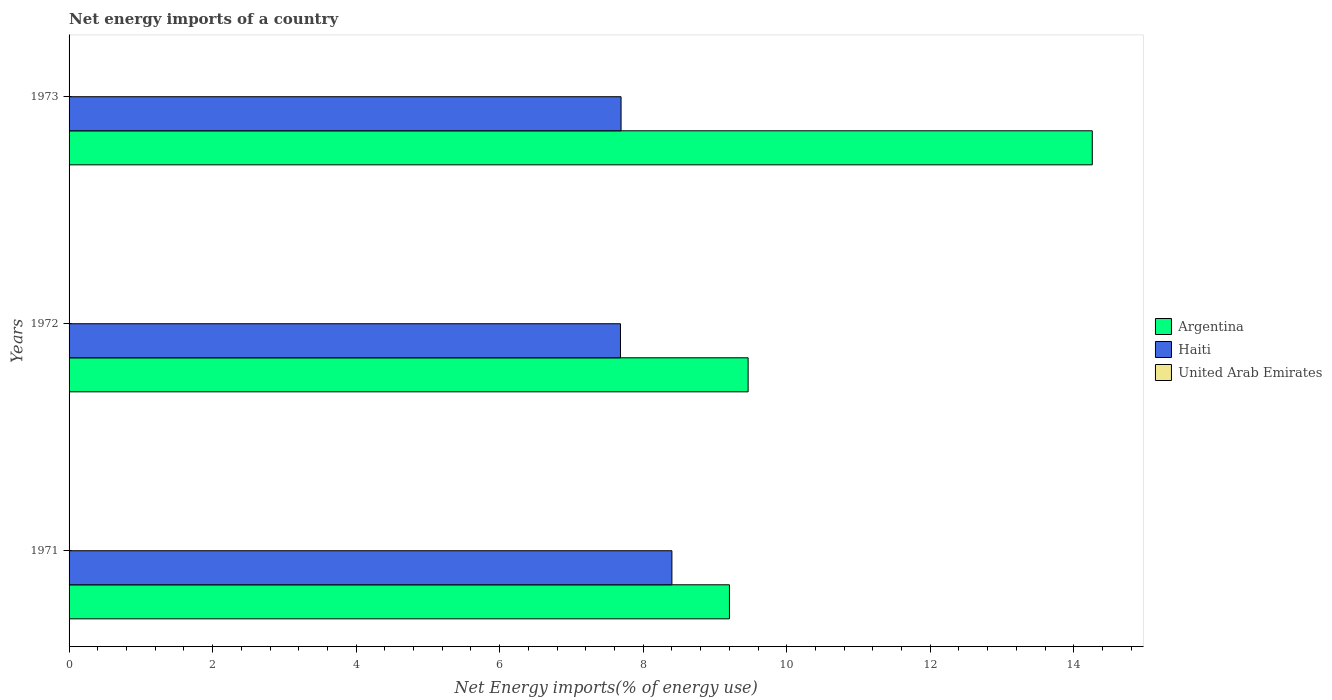How many different coloured bars are there?
Make the answer very short. 2. Are the number of bars per tick equal to the number of legend labels?
Your answer should be compact. No. Are the number of bars on each tick of the Y-axis equal?
Provide a short and direct response. Yes. How many bars are there on the 3rd tick from the top?
Give a very brief answer. 2. In how many cases, is the number of bars for a given year not equal to the number of legend labels?
Give a very brief answer. 3. What is the net energy imports in Haiti in 1971?
Ensure brevity in your answer.  8.4. Across all years, what is the maximum net energy imports in Argentina?
Give a very brief answer. 14.26. Across all years, what is the minimum net energy imports in Haiti?
Give a very brief answer. 7.68. What is the total net energy imports in Haiti in the graph?
Provide a succinct answer. 23.78. What is the difference between the net energy imports in Haiti in 1972 and that in 1973?
Give a very brief answer. -0.01. What is the difference between the net energy imports in Argentina in 1971 and the net energy imports in Haiti in 1972?
Provide a short and direct response. 1.52. What is the average net energy imports in Haiti per year?
Ensure brevity in your answer.  7.93. In the year 1973, what is the difference between the net energy imports in Haiti and net energy imports in Argentina?
Provide a succinct answer. -6.57. What is the ratio of the net energy imports in Haiti in 1971 to that in 1973?
Make the answer very short. 1.09. Is the net energy imports in Argentina in 1971 less than that in 1972?
Your answer should be very brief. Yes. Is the difference between the net energy imports in Haiti in 1971 and 1973 greater than the difference between the net energy imports in Argentina in 1971 and 1973?
Provide a short and direct response. Yes. What is the difference between the highest and the second highest net energy imports in Argentina?
Your response must be concise. 4.8. What is the difference between the highest and the lowest net energy imports in Argentina?
Keep it short and to the point. 5.06. Is the sum of the net energy imports in Haiti in 1972 and 1973 greater than the maximum net energy imports in Argentina across all years?
Keep it short and to the point. Yes. Are the values on the major ticks of X-axis written in scientific E-notation?
Offer a terse response. No. Where does the legend appear in the graph?
Offer a very short reply. Center right. How many legend labels are there?
Ensure brevity in your answer.  3. How are the legend labels stacked?
Your answer should be compact. Vertical. What is the title of the graph?
Provide a succinct answer. Net energy imports of a country. Does "Maldives" appear as one of the legend labels in the graph?
Provide a short and direct response. No. What is the label or title of the X-axis?
Give a very brief answer. Net Energy imports(% of energy use). What is the Net Energy imports(% of energy use) of Argentina in 1971?
Offer a very short reply. 9.2. What is the Net Energy imports(% of energy use) in Haiti in 1971?
Your answer should be very brief. 8.4. What is the Net Energy imports(% of energy use) of United Arab Emirates in 1971?
Your answer should be very brief. 0. What is the Net Energy imports(% of energy use) in Argentina in 1972?
Ensure brevity in your answer.  9.46. What is the Net Energy imports(% of energy use) in Haiti in 1972?
Your answer should be very brief. 7.68. What is the Net Energy imports(% of energy use) in Argentina in 1973?
Offer a very short reply. 14.26. What is the Net Energy imports(% of energy use) in Haiti in 1973?
Offer a terse response. 7.69. Across all years, what is the maximum Net Energy imports(% of energy use) of Argentina?
Provide a succinct answer. 14.26. Across all years, what is the maximum Net Energy imports(% of energy use) of Haiti?
Provide a short and direct response. 8.4. Across all years, what is the minimum Net Energy imports(% of energy use) in Argentina?
Your response must be concise. 9.2. Across all years, what is the minimum Net Energy imports(% of energy use) in Haiti?
Your answer should be compact. 7.68. What is the total Net Energy imports(% of energy use) in Argentina in the graph?
Your response must be concise. 32.92. What is the total Net Energy imports(% of energy use) of Haiti in the graph?
Give a very brief answer. 23.78. What is the total Net Energy imports(% of energy use) of United Arab Emirates in the graph?
Make the answer very short. 0. What is the difference between the Net Energy imports(% of energy use) in Argentina in 1971 and that in 1972?
Ensure brevity in your answer.  -0.26. What is the difference between the Net Energy imports(% of energy use) in Haiti in 1971 and that in 1972?
Make the answer very short. 0.72. What is the difference between the Net Energy imports(% of energy use) in Argentina in 1971 and that in 1973?
Ensure brevity in your answer.  -5.06. What is the difference between the Net Energy imports(% of energy use) of Haiti in 1971 and that in 1973?
Your answer should be very brief. 0.71. What is the difference between the Net Energy imports(% of energy use) of Argentina in 1972 and that in 1973?
Offer a terse response. -4.8. What is the difference between the Net Energy imports(% of energy use) in Haiti in 1972 and that in 1973?
Your answer should be compact. -0.01. What is the difference between the Net Energy imports(% of energy use) of Argentina in 1971 and the Net Energy imports(% of energy use) of Haiti in 1972?
Your response must be concise. 1.52. What is the difference between the Net Energy imports(% of energy use) in Argentina in 1971 and the Net Energy imports(% of energy use) in Haiti in 1973?
Your answer should be very brief. 1.51. What is the difference between the Net Energy imports(% of energy use) in Argentina in 1972 and the Net Energy imports(% of energy use) in Haiti in 1973?
Make the answer very short. 1.77. What is the average Net Energy imports(% of energy use) of Argentina per year?
Offer a very short reply. 10.97. What is the average Net Energy imports(% of energy use) of Haiti per year?
Offer a terse response. 7.93. In the year 1971, what is the difference between the Net Energy imports(% of energy use) in Argentina and Net Energy imports(% of energy use) in Haiti?
Ensure brevity in your answer.  0.8. In the year 1972, what is the difference between the Net Energy imports(% of energy use) of Argentina and Net Energy imports(% of energy use) of Haiti?
Give a very brief answer. 1.78. In the year 1973, what is the difference between the Net Energy imports(% of energy use) of Argentina and Net Energy imports(% of energy use) of Haiti?
Your answer should be compact. 6.57. What is the ratio of the Net Energy imports(% of energy use) in Argentina in 1971 to that in 1972?
Make the answer very short. 0.97. What is the ratio of the Net Energy imports(% of energy use) of Haiti in 1971 to that in 1972?
Your answer should be compact. 1.09. What is the ratio of the Net Energy imports(% of energy use) in Argentina in 1971 to that in 1973?
Your answer should be compact. 0.65. What is the ratio of the Net Energy imports(% of energy use) of Haiti in 1971 to that in 1973?
Offer a very short reply. 1.09. What is the ratio of the Net Energy imports(% of energy use) of Argentina in 1972 to that in 1973?
Your answer should be very brief. 0.66. What is the ratio of the Net Energy imports(% of energy use) in Haiti in 1972 to that in 1973?
Give a very brief answer. 1. What is the difference between the highest and the second highest Net Energy imports(% of energy use) of Argentina?
Provide a short and direct response. 4.8. What is the difference between the highest and the second highest Net Energy imports(% of energy use) of Haiti?
Your response must be concise. 0.71. What is the difference between the highest and the lowest Net Energy imports(% of energy use) of Argentina?
Provide a succinct answer. 5.06. What is the difference between the highest and the lowest Net Energy imports(% of energy use) of Haiti?
Your answer should be very brief. 0.72. 